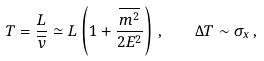Convert formula to latex. <formula><loc_0><loc_0><loc_500><loc_500>T = \frac { L } { \overline { v } } \simeq L \left ( 1 + \frac { \overline { m ^ { 2 } } } { 2 E ^ { 2 } } \right ) \, , \quad \Delta T \sim \sigma _ { x } \, ,</formula> 